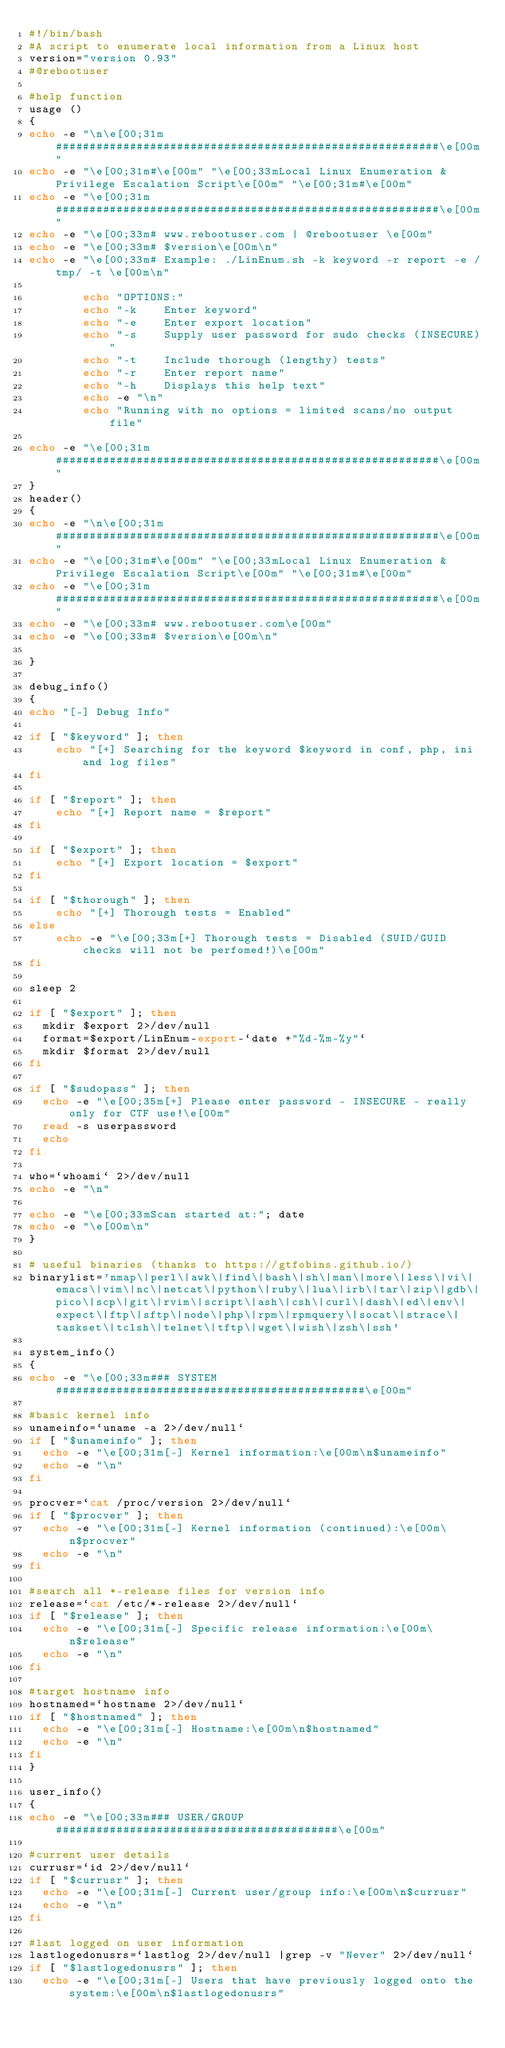Convert code to text. <code><loc_0><loc_0><loc_500><loc_500><_Bash_>#!/bin/bash
#A script to enumerate local information from a Linux host
version="version 0.93"
#@rebootuser

#help function
usage () 
{ 
echo -e "\n\e[00;31m#########################################################\e[00m" 
echo -e "\e[00;31m#\e[00m" "\e[00;33mLocal Linux Enumeration & Privilege Escalation Script\e[00m" "\e[00;31m#\e[00m"
echo -e "\e[00;31m#########################################################\e[00m"
echo -e "\e[00;33m# www.rebootuser.com | @rebootuser \e[00m"
echo -e "\e[00;33m# $version\e[00m\n"
echo -e "\e[00;33m# Example: ./LinEnum.sh -k keyword -r report -e /tmp/ -t \e[00m\n"

		echo "OPTIONS:"
		echo "-k	Enter keyword"
		echo "-e	Enter export location"
		echo "-s 	Supply user password for sudo checks (INSECURE)"
		echo "-t	Include thorough (lengthy) tests"
		echo "-r	Enter report name" 
		echo "-h	Displays this help text"
		echo -e "\n"
		echo "Running with no options = limited scans/no output file"
		
echo -e "\e[00;31m#########################################################\e[00m"		
}
header()
{
echo -e "\n\e[00;31m#########################################################\e[00m" 
echo -e "\e[00;31m#\e[00m" "\e[00;33mLocal Linux Enumeration & Privilege Escalation Script\e[00m" "\e[00;31m#\e[00m" 
echo -e "\e[00;31m#########################################################\e[00m" 
echo -e "\e[00;33m# www.rebootuser.com\e[00m" 
echo -e "\e[00;33m# $version\e[00m\n" 

}

debug_info()
{
echo "[-] Debug Info" 

if [ "$keyword" ]; then 
	echo "[+] Searching for the keyword $keyword in conf, php, ini and log files" 
fi

if [ "$report" ]; then 
	echo "[+] Report name = $report" 
fi

if [ "$export" ]; then 
	echo "[+] Export location = $export" 
fi

if [ "$thorough" ]; then 
	echo "[+] Thorough tests = Enabled" 
else 
	echo -e "\e[00;33m[+] Thorough tests = Disabled (SUID/GUID checks will not be perfomed!)\e[00m" 
fi

sleep 2

if [ "$export" ]; then
  mkdir $export 2>/dev/null
  format=$export/LinEnum-export-`date +"%d-%m-%y"`
  mkdir $format 2>/dev/null
fi

if [ "$sudopass" ]; then 
  echo -e "\e[00;35m[+] Please enter password - INSECURE - really only for CTF use!\e[00m"
  read -s userpassword
  echo 
fi

who=`whoami` 2>/dev/null 
echo -e "\n" 

echo -e "\e[00;33mScan started at:"; date 
echo -e "\e[00m\n" 
}

# useful binaries (thanks to https://gtfobins.github.io/)
binarylist='nmap\|perl\|awk\|find\|bash\|sh\|man\|more\|less\|vi\|emacs\|vim\|nc\|netcat\|python\|ruby\|lua\|irb\|tar\|zip\|gdb\|pico\|scp\|git\|rvim\|script\|ash\|csh\|curl\|dash\|ed\|env\|expect\|ftp\|sftp\|node\|php\|rpm\|rpmquery\|socat\|strace\|taskset\|tclsh\|telnet\|tftp\|wget\|wish\|zsh\|ssh'

system_info()
{
echo -e "\e[00;33m### SYSTEM ##############################################\e[00m" 

#basic kernel info
unameinfo=`uname -a 2>/dev/null`
if [ "$unameinfo" ]; then
  echo -e "\e[00;31m[-] Kernel information:\e[00m\n$unameinfo" 
  echo -e "\n" 
fi

procver=`cat /proc/version 2>/dev/null`
if [ "$procver" ]; then
  echo -e "\e[00;31m[-] Kernel information (continued):\e[00m\n$procver" 
  echo -e "\n" 
fi

#search all *-release files for version info
release=`cat /etc/*-release 2>/dev/null`
if [ "$release" ]; then
  echo -e "\e[00;31m[-] Specific release information:\e[00m\n$release" 
  echo -e "\n" 
fi

#target hostname info
hostnamed=`hostname 2>/dev/null`
if [ "$hostnamed" ]; then
  echo -e "\e[00;31m[-] Hostname:\e[00m\n$hostnamed" 
  echo -e "\n" 
fi
}

user_info()
{
echo -e "\e[00;33m### USER/GROUP ##########################################\e[00m" 

#current user details
currusr=`id 2>/dev/null`
if [ "$currusr" ]; then
  echo -e "\e[00;31m[-] Current user/group info:\e[00m\n$currusr" 
  echo -e "\n"
fi

#last logged on user information
lastlogedonusrs=`lastlog 2>/dev/null |grep -v "Never" 2>/dev/null`
if [ "$lastlogedonusrs" ]; then
  echo -e "\e[00;31m[-] Users that have previously logged onto the system:\e[00m\n$lastlogedonusrs" </code> 